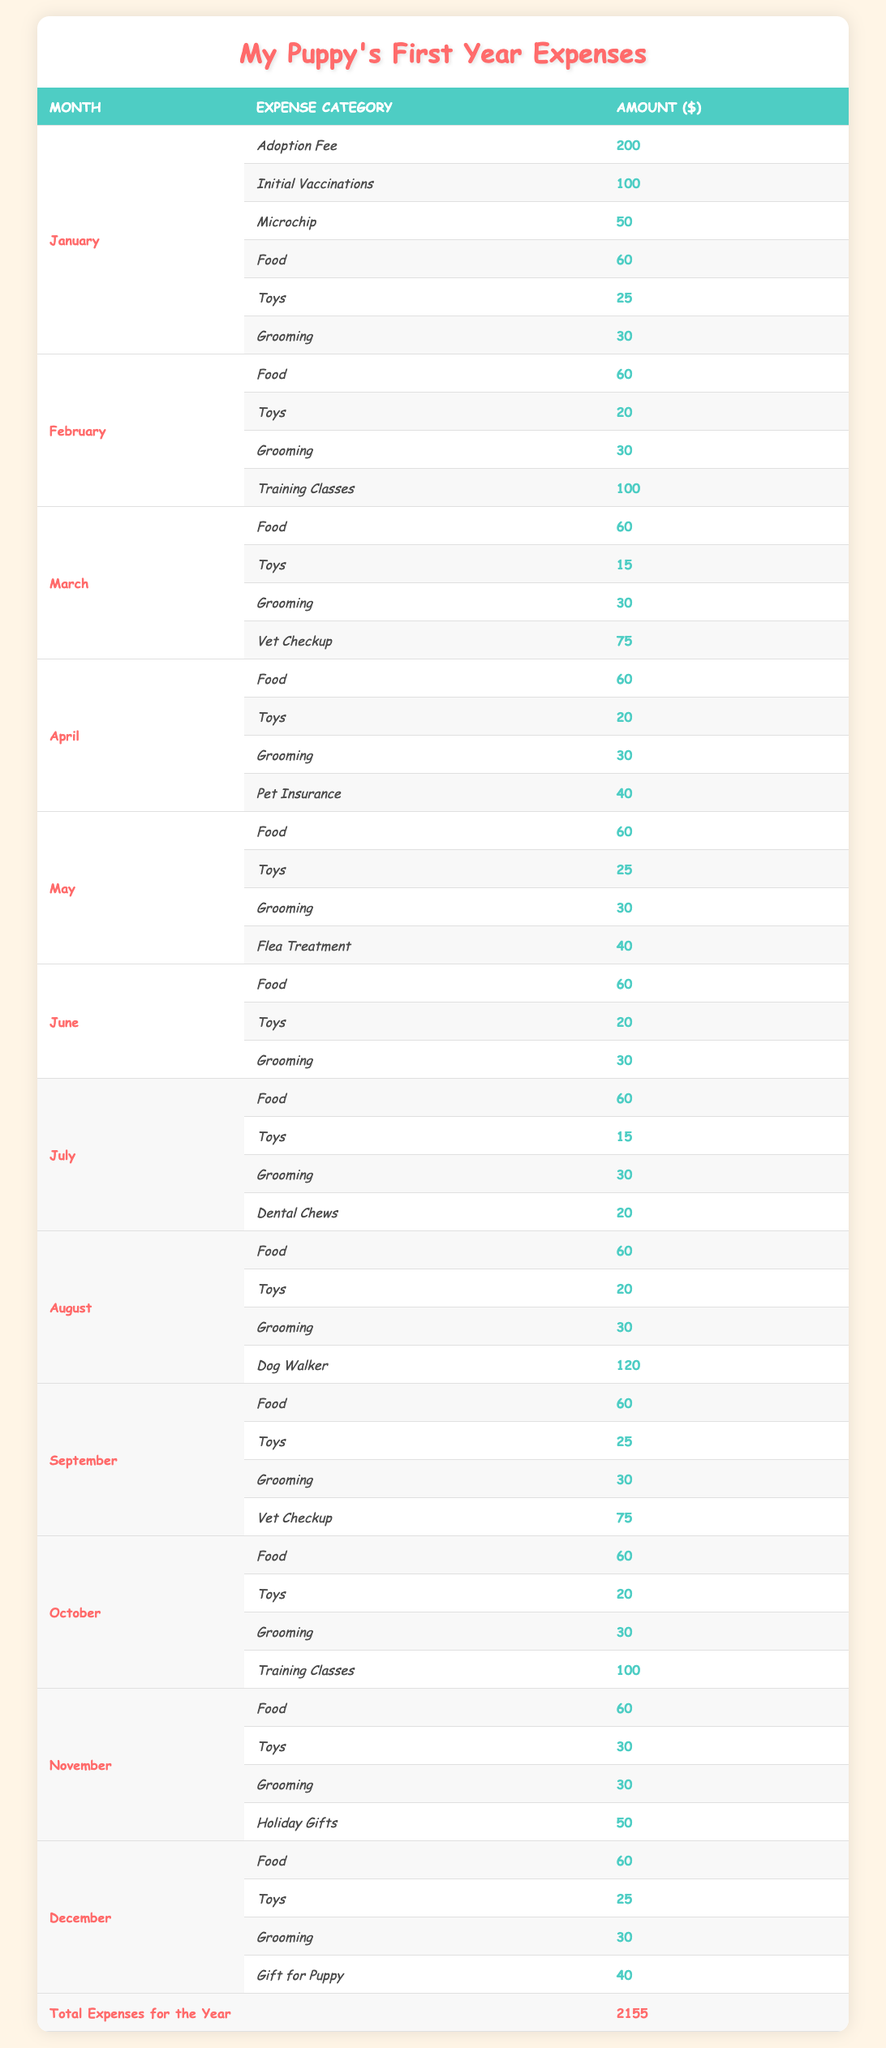What's the total amount spent on food for the entire year? To find the total amount spent on food, we can add the monthly food expenses from January to December: 60 + 60 + 60 + 60 + 60 + 60 + 60 + 60 + 60 + 60 + 60 + 60 = 720.
Answer: 720 How much did the initial costs in January total? The initial costs in January include the Adoption Fee (200), Initial Vaccinations (100), and Microchip (50). Adding these up gives: 200 + 100 + 50 = 350.
Answer: 350 Did the monthly costs for August exceed 200 dollars? In August, the monthly costs are: Food (60), Toys (20), Grooming (30), and Dog Walker (120). The total is 60 + 20 + 30 + 120 = 230, which is greater than 200.
Answer: Yes What was the highest single expense category in any month? By reviewing the expenses month by month, we find that the highest single expense is the Dog Walker in August for 120 dollars, which exceeds all other individual expenses.
Answer: 120 What is the average monthly spending on grooming across the year? The grooming expenses for each month are: January (30), February (30), March (30), April (30), May (30), June (30), July (30), August (30), September (30), October (30), November (30), December (30). There are 12 months, so the total is 30 * 12 = 360. Dividing by 12 gives an average of 30.
Answer: 30 Which month had the highest total expense? First, calculate the total expenses for each month: January (350 + 60 + 25 + 30 = 465), February (60 + 20 + 30 + 100 = 210), March (60 + 15 + 30 + 75 = 180), April (60 + 20 + 30 + 40 = 150), May (60 + 25 + 30 + 40 = 155), June (60 + 20 + 30 = 110), July (60 + 15 + 30 + 20 = 125), August (60 + 20 + 30 + 120 = 230), September (60 + 25 + 30 + 75 = 190), October (60 + 20 + 30 + 100 = 210), November (60 + 30 + 30 + 50 = 170), December (60 + 25 + 30 + 40 = 155). The highest total is January with 465.
Answer: January How many months included training classes as an expense? Training classes were indicated in February and October, counting them gives us a total of 2 months that included this expense.
Answer: 2 Was the total of holiday gifts more than the total of dental chews? The holiday gifts in November cost 50, and the dental chews in July cost 20. Since 50 is greater than 20, the statement is true.
Answer: Yes 